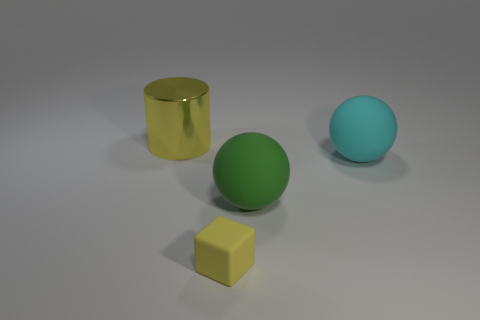Add 3 big rubber balls. How many objects exist? 7 Subtract all cylinders. How many objects are left? 3 Add 4 yellow rubber objects. How many yellow rubber objects exist? 5 Subtract 0 purple cylinders. How many objects are left? 4 Subtract all cyan balls. Subtract all balls. How many objects are left? 1 Add 1 large metallic cylinders. How many large metallic cylinders are left? 2 